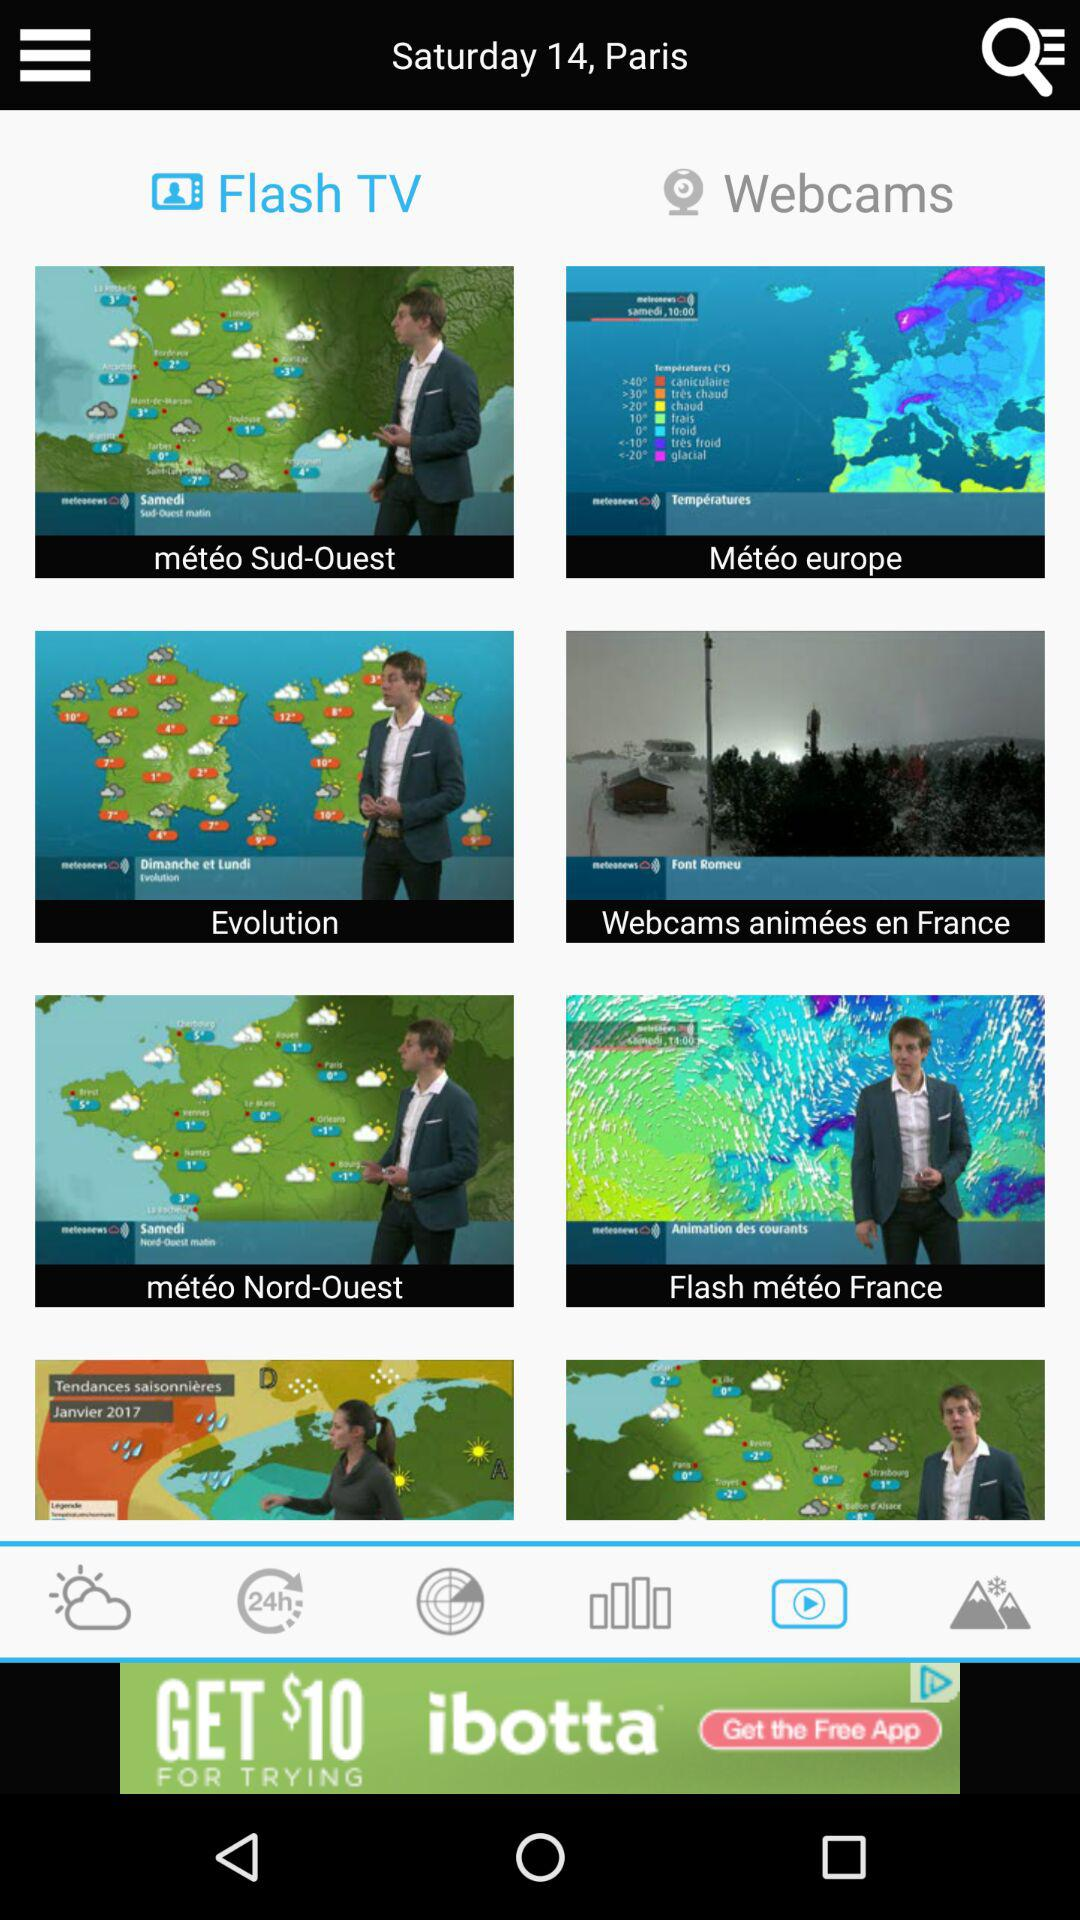What is the mentioned day? The mentioned day is Saturday, 14. 